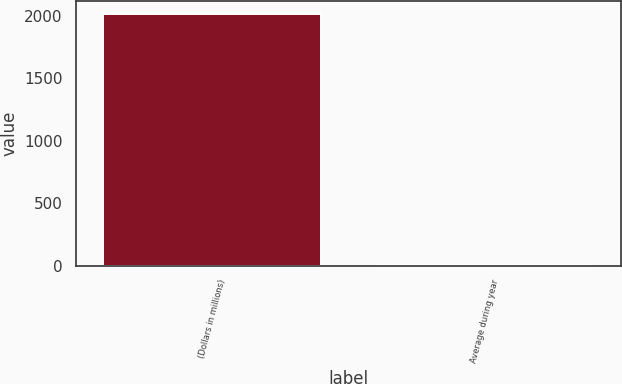<chart> <loc_0><loc_0><loc_500><loc_500><bar_chart><fcel>(Dollars in millions)<fcel>Average during year<nl><fcel>2017<fcel>0.81<nl></chart> 